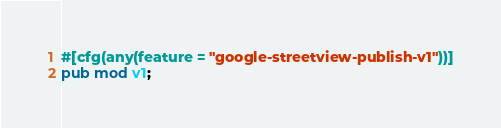<code> <loc_0><loc_0><loc_500><loc_500><_Rust_>#[cfg(any(feature = "google-streetview-publish-v1"))]
pub mod v1;
</code> 